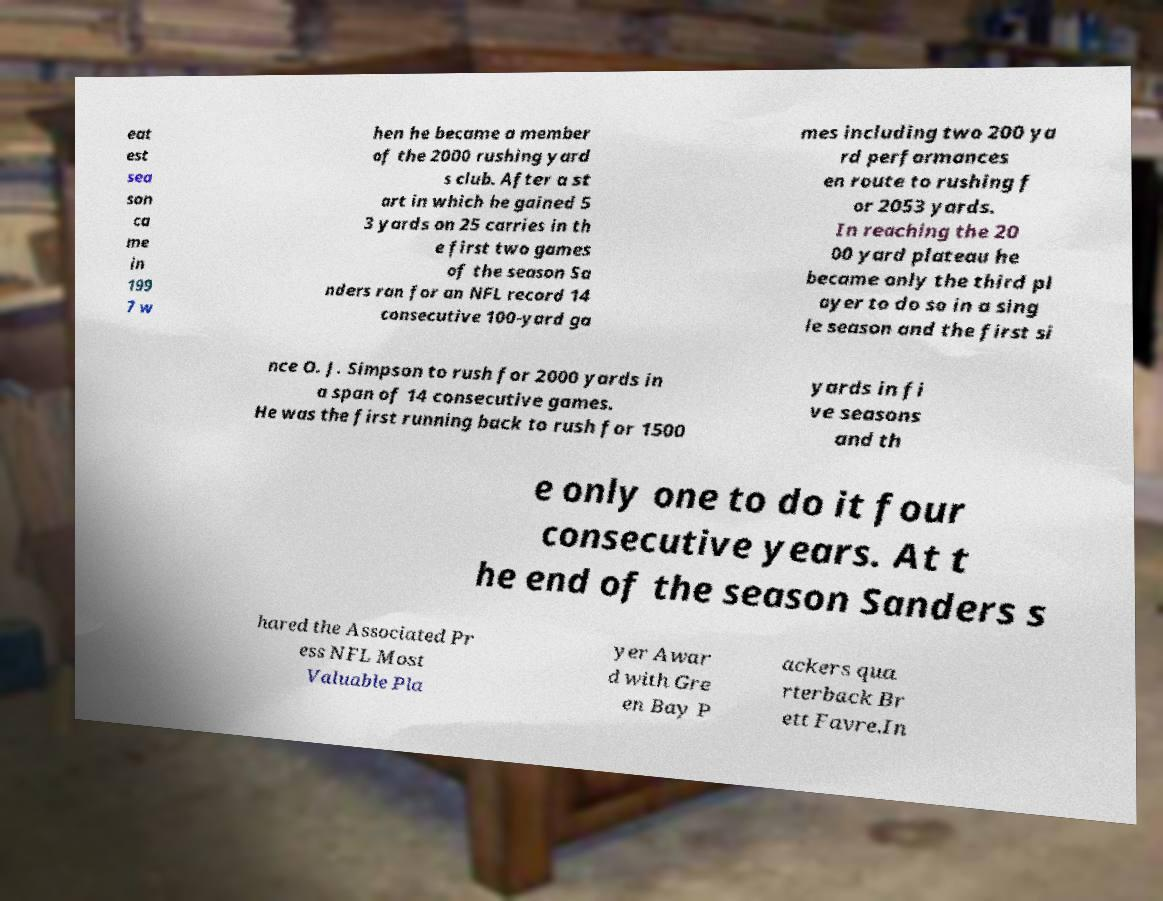Could you extract and type out the text from this image? eat est sea son ca me in 199 7 w hen he became a member of the 2000 rushing yard s club. After a st art in which he gained 5 3 yards on 25 carries in th e first two games of the season Sa nders ran for an NFL record 14 consecutive 100-yard ga mes including two 200 ya rd performances en route to rushing f or 2053 yards. In reaching the 20 00 yard plateau he became only the third pl ayer to do so in a sing le season and the first si nce O. J. Simpson to rush for 2000 yards in a span of 14 consecutive games. He was the first running back to rush for 1500 yards in fi ve seasons and th e only one to do it four consecutive years. At t he end of the season Sanders s hared the Associated Pr ess NFL Most Valuable Pla yer Awar d with Gre en Bay P ackers qua rterback Br ett Favre.In 